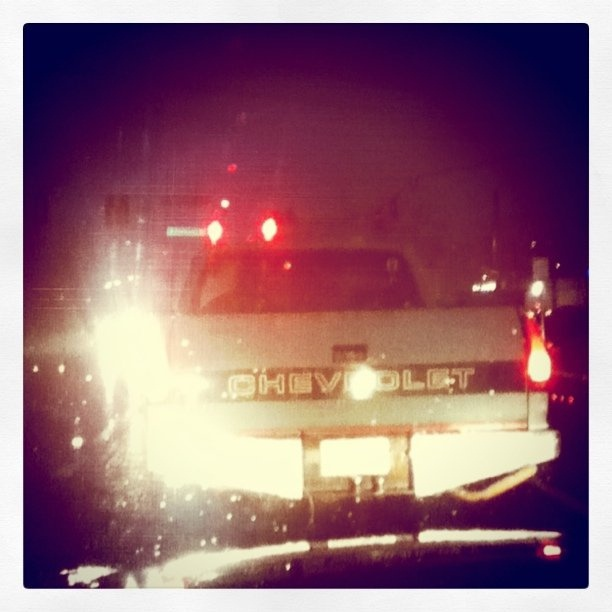Describe the objects in this image and their specific colors. I can see truck in white, lightyellow, tan, and brown tones, traffic light in white, salmon, lightyellow, and red tones, and traffic light in white, lightyellow, salmon, and tan tones in this image. 